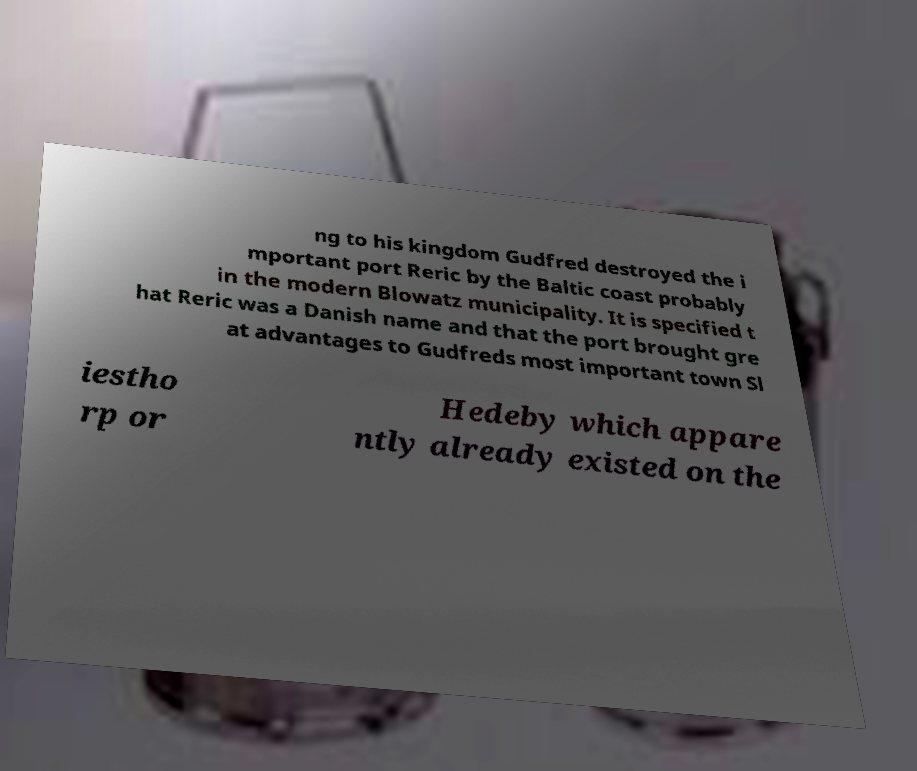There's text embedded in this image that I need extracted. Can you transcribe it verbatim? ng to his kingdom Gudfred destroyed the i mportant port Reric by the Baltic coast probably in the modern Blowatz municipality. It is specified t hat Reric was a Danish name and that the port brought gre at advantages to Gudfreds most important town Sl iestho rp or Hedeby which appare ntly already existed on the 